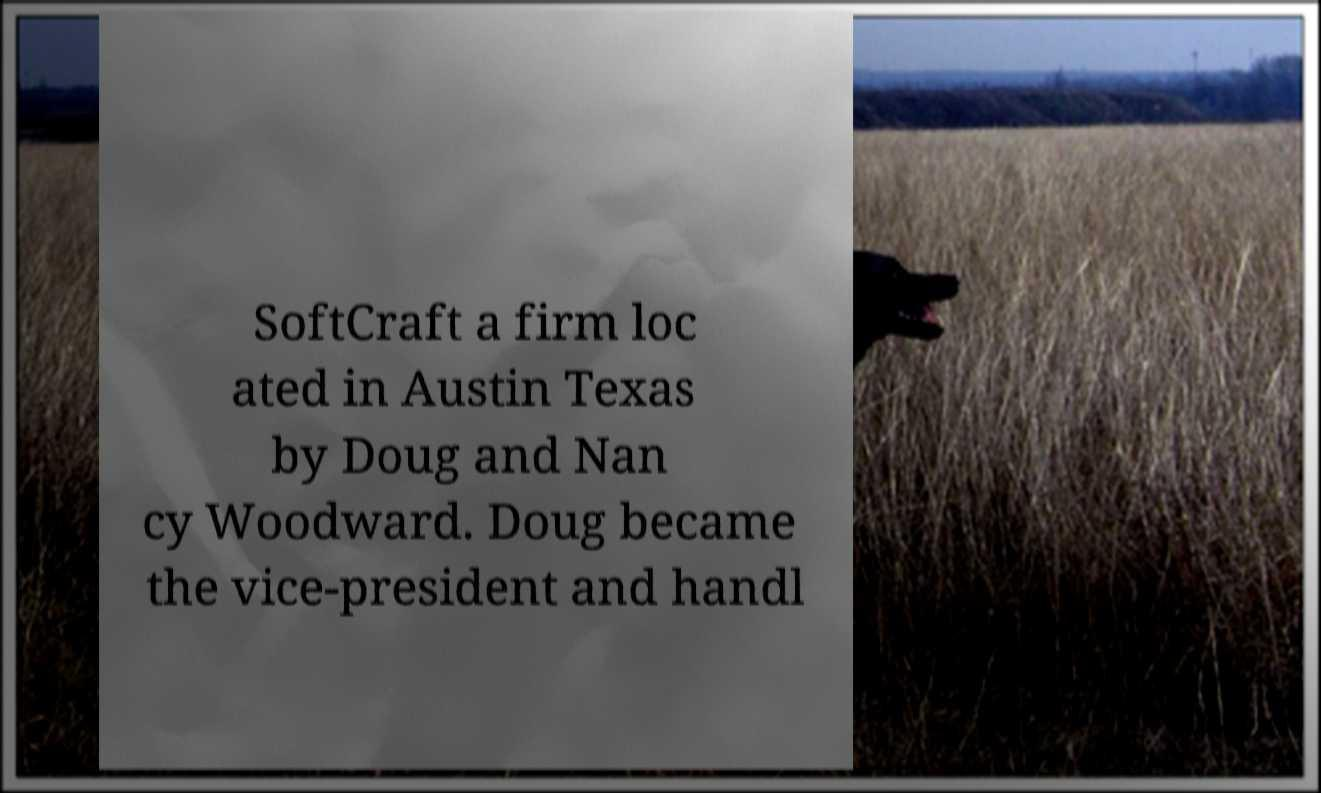Can you accurately transcribe the text from the provided image for me? SoftCraft a firm loc ated in Austin Texas by Doug and Nan cy Woodward. Doug became the vice-president and handl 